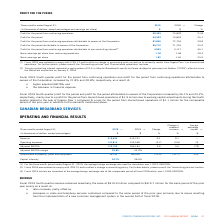According to Cogeco's financial document, How much was the Fiscal 2019 fourth-quarter profit for the period increase from continuing operations? According to the financial document, 21.8%. The relevant text states: "ibutable to owners of the Corporation increased by 21.8% and 20.8%, respectively, as a result of:..." Also, How much was the profit increase for the period from continuing operations attributable to owners of the Corporation? According to the financial document, 20.8%. The relevant text states: "o owners of the Corporation increased by 21.8% and 20.8%, respectively, as a result of:..." Also, What led to increase in the Fiscal 2019 fourth-quarter profit for the period and profit for the period attributable to owners of the Corporation? mainly due to a profit for the period from discontinued operations of $1.9 million due to working capital adjustments during the fourth quarter related to the sale of Cogeco Peer 1 compared to a loss for the period from discontinued operations of $1.1 million for the comparable period of the prior year in addition to the elements mentioned above.. The document states: "ration increased by 26.1% and 25.2%, respectively, mainly due to a profit for the period from discontinued operations of $1.9 million due to working c..." Also, can you calculate: What is the increase/ (decrease) in Profit for the period from continuing operations from 2018 to 2019? Based on the calculation: 92,403-75,870, the result is 16533 (in thousands). This is based on the information: "for the period from continuing operations 92,403 75,870 21.8 Profit for the period from continuing operations 92,403 75,870 21.8..." The key data points involved are: 75,870, 92,403. Also, can you calculate: What is the increase/ (decrease) in Profit for the period from continuing operations attributable to owners of the Corporation from 2018 to 2019? Based on the calculation: 87,850-72,753, the result is 15097 (in thousands). This is based on the information: "rations attributable to owners of the Corporation 87,850 72,753 20.8 attributable to owners of the Corporation 87,850 72,753 20.8..." The key data points involved are: 72,753, 87,850. Also, can you calculate: What is the increase/ (decrease) in Profit for the period attributable to owners of the Corporation from 2018 to 2019? Based on the calculation: 89,770-71,701, the result is 18069 (in thousands). This is based on the information: "attributable to owners of the Corporation 89,770 71,701 25.2 period attributable to owners of the Corporation 89,770 71,701 25.2..." The key data points involved are: 71,701, 89,770. 